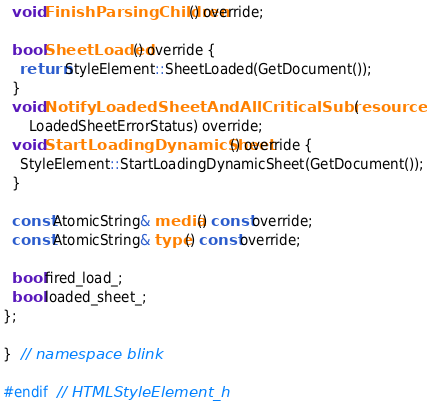<code> <loc_0><loc_0><loc_500><loc_500><_C_>  void FinishParsingChildren() override;

  bool SheetLoaded() override {
    return StyleElement::SheetLoaded(GetDocument());
  }
  void NotifyLoadedSheetAndAllCriticalSubresources(
      LoadedSheetErrorStatus) override;
  void StartLoadingDynamicSheet() override {
    StyleElement::StartLoadingDynamicSheet(GetDocument());
  }

  const AtomicString& media() const override;
  const AtomicString& type() const override;

  bool fired_load_;
  bool loaded_sheet_;
};

}  // namespace blink

#endif  // HTMLStyleElement_h
</code> 